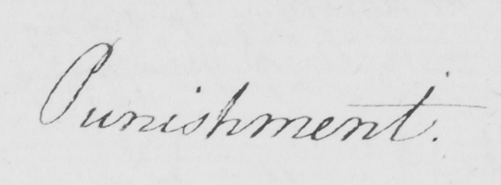Can you read and transcribe this handwriting? Punishment . 